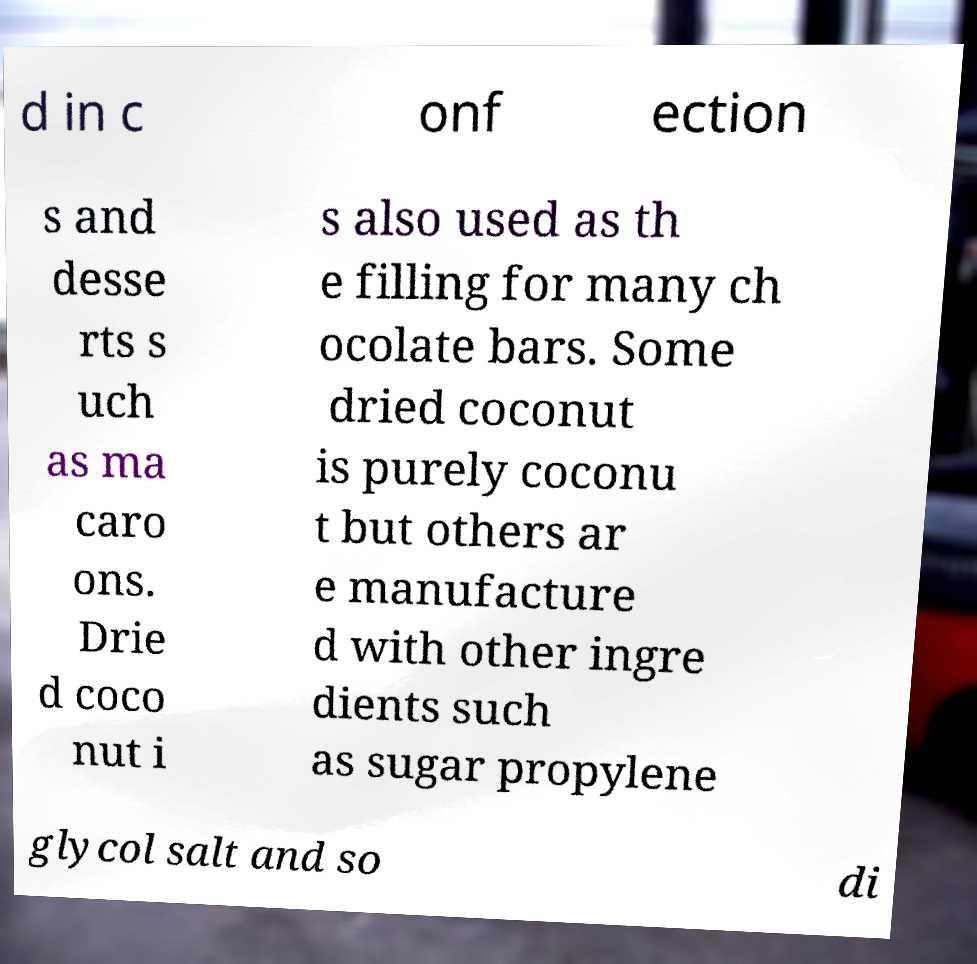Please identify and transcribe the text found in this image. d in c onf ection s and desse rts s uch as ma caro ons. Drie d coco nut i s also used as th e filling for many ch ocolate bars. Some dried coconut is purely coconu t but others ar e manufacture d with other ingre dients such as sugar propylene glycol salt and so di 